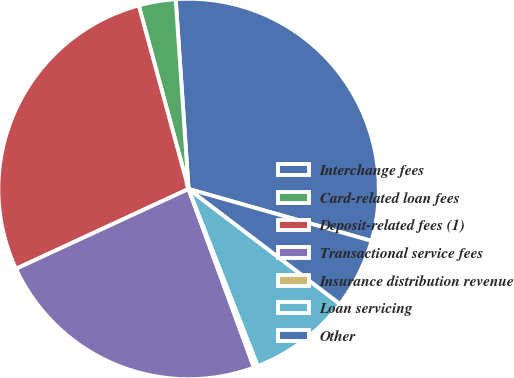Convert chart to OTSL. <chart><loc_0><loc_0><loc_500><loc_500><pie_chart><fcel>Interchange fees<fcel>Card-related loan fees<fcel>Deposit-related fees (1)<fcel>Transactional service fees<fcel>Insurance distribution revenue<fcel>Loan servicing<fcel>Other<nl><fcel>30.48%<fcel>3.14%<fcel>27.68%<fcel>23.69%<fcel>0.34%<fcel>8.73%<fcel>5.94%<nl></chart> 